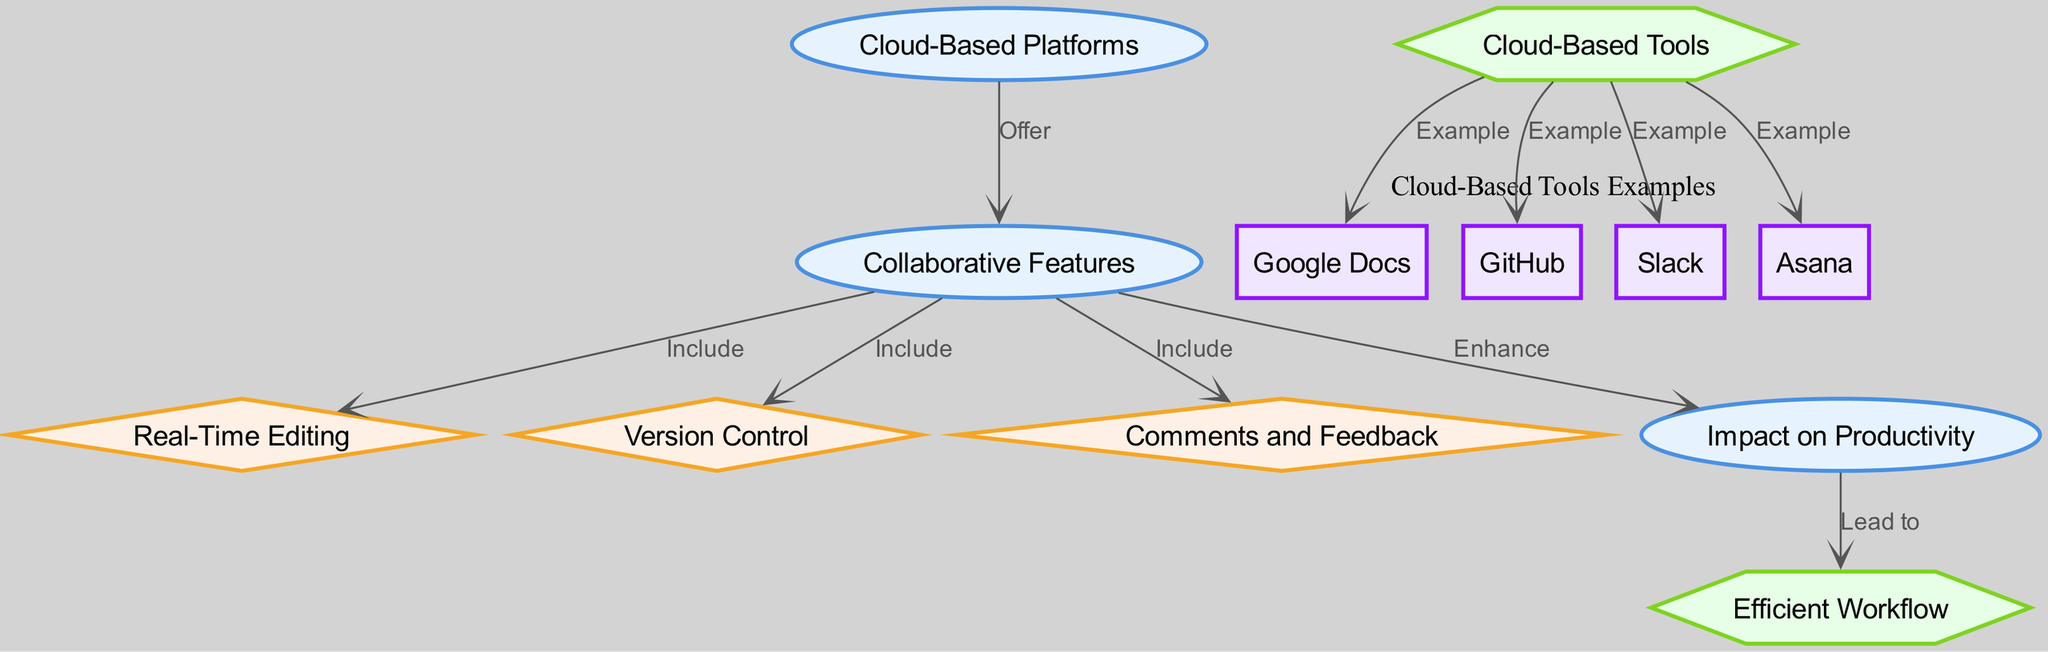What are the collaborative features included in cloud-based platforms? The diagram indicates that collaborative features include real-time editing, version control, and comments and feedback. By looking at the connections stemming from the "Collaborative Features" node, it is clear that three specific features are outlined.
Answer: real-time editing, version control, comments and feedback How many examples of cloud-based tools are presented in the diagram? The diagram lists four examples of cloud-based tools: Google Docs, GitHub, Slack, and Asana. By counting the nodes under the "Cloud-Based Tools Examples" cluster, we can determine the total number of tools mentioned.
Answer: 4 What impact do collaborative features have according to the diagram? The diagram shows that collaborative features enhance productivity, as indicated by the link from "Collaborative Features" to "Impact on Productivity." This direct relation simplifies the answer to what kind of impact is reported.
Answer: Enhance Which node directly leads to an efficient workflow? According to the diagram, the node "Impact on Productivity" leads directly to "Efficient Workflow." By following the edge connection from productivity, it becomes evident which concept links to the efficient workflow.
Answer: Impact on Productivity What type of node is "version control"? Looking at the diagram, "version control" is categorized as a diamond-shaped node. By examining the node's characteristics and its connections, we can identify its type within the diagram's structure.
Answer: diamond Which cloud-based tool is an example of version control? The diagram does not directly categorize any cloud-based tool as an example of version control; instead, it lists GitHub as a tool in the cluster while indicating "version control" as a distinct feature. However, GitHub is known for version control, thus associating it indirectly with that feature.
Answer: GitHub What does the "collaborative features" node enhance? The diagram illustrates that the "Collaborative Features" node enhances "Impact on Productivity." By tracking the relational arrows from "Collaborative Features," this connection can be traced easily to determine what is being enhanced.
Answer: Impact on Productivity How is the relationship between "productivity" and "workflow" described? The relationship from "productivity" to "workflow" is described as leading to an efficient workflow. This link shows the expected outcome stemming from productivity in the context of enhancing workflow efficiency.
Answer: Lead to 